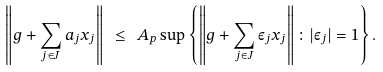<formula> <loc_0><loc_0><loc_500><loc_500>\left \| g + \sum _ { j \in J } a _ { j } x _ { j } \right \| \ \leq \ A _ { p } \sup \left \{ \left \| g + \sum _ { j \in J } \varepsilon _ { j } x _ { j } \right \| \colon | \varepsilon _ { j } | = 1 \right \} .</formula> 